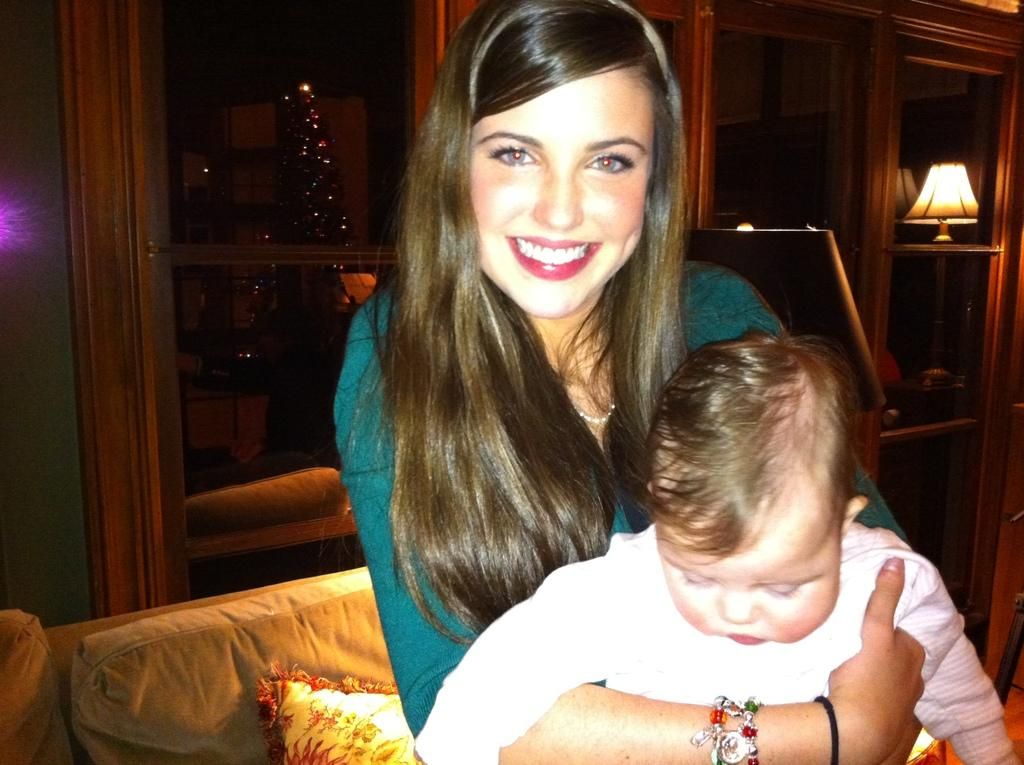What is the woman in the image doing? The woman is holding a child in the image. What type of furniture is present in the image? There is a sofa with a cushion on it in the image. What is the lighting source in the image? There is a lamp on a wooden surface in the image. What can be seen on the wall in the image? There is a tree decorated with lights in the image. What type of lipstick is the bat wearing in the image? There is no bat or lipstick present in the image. 